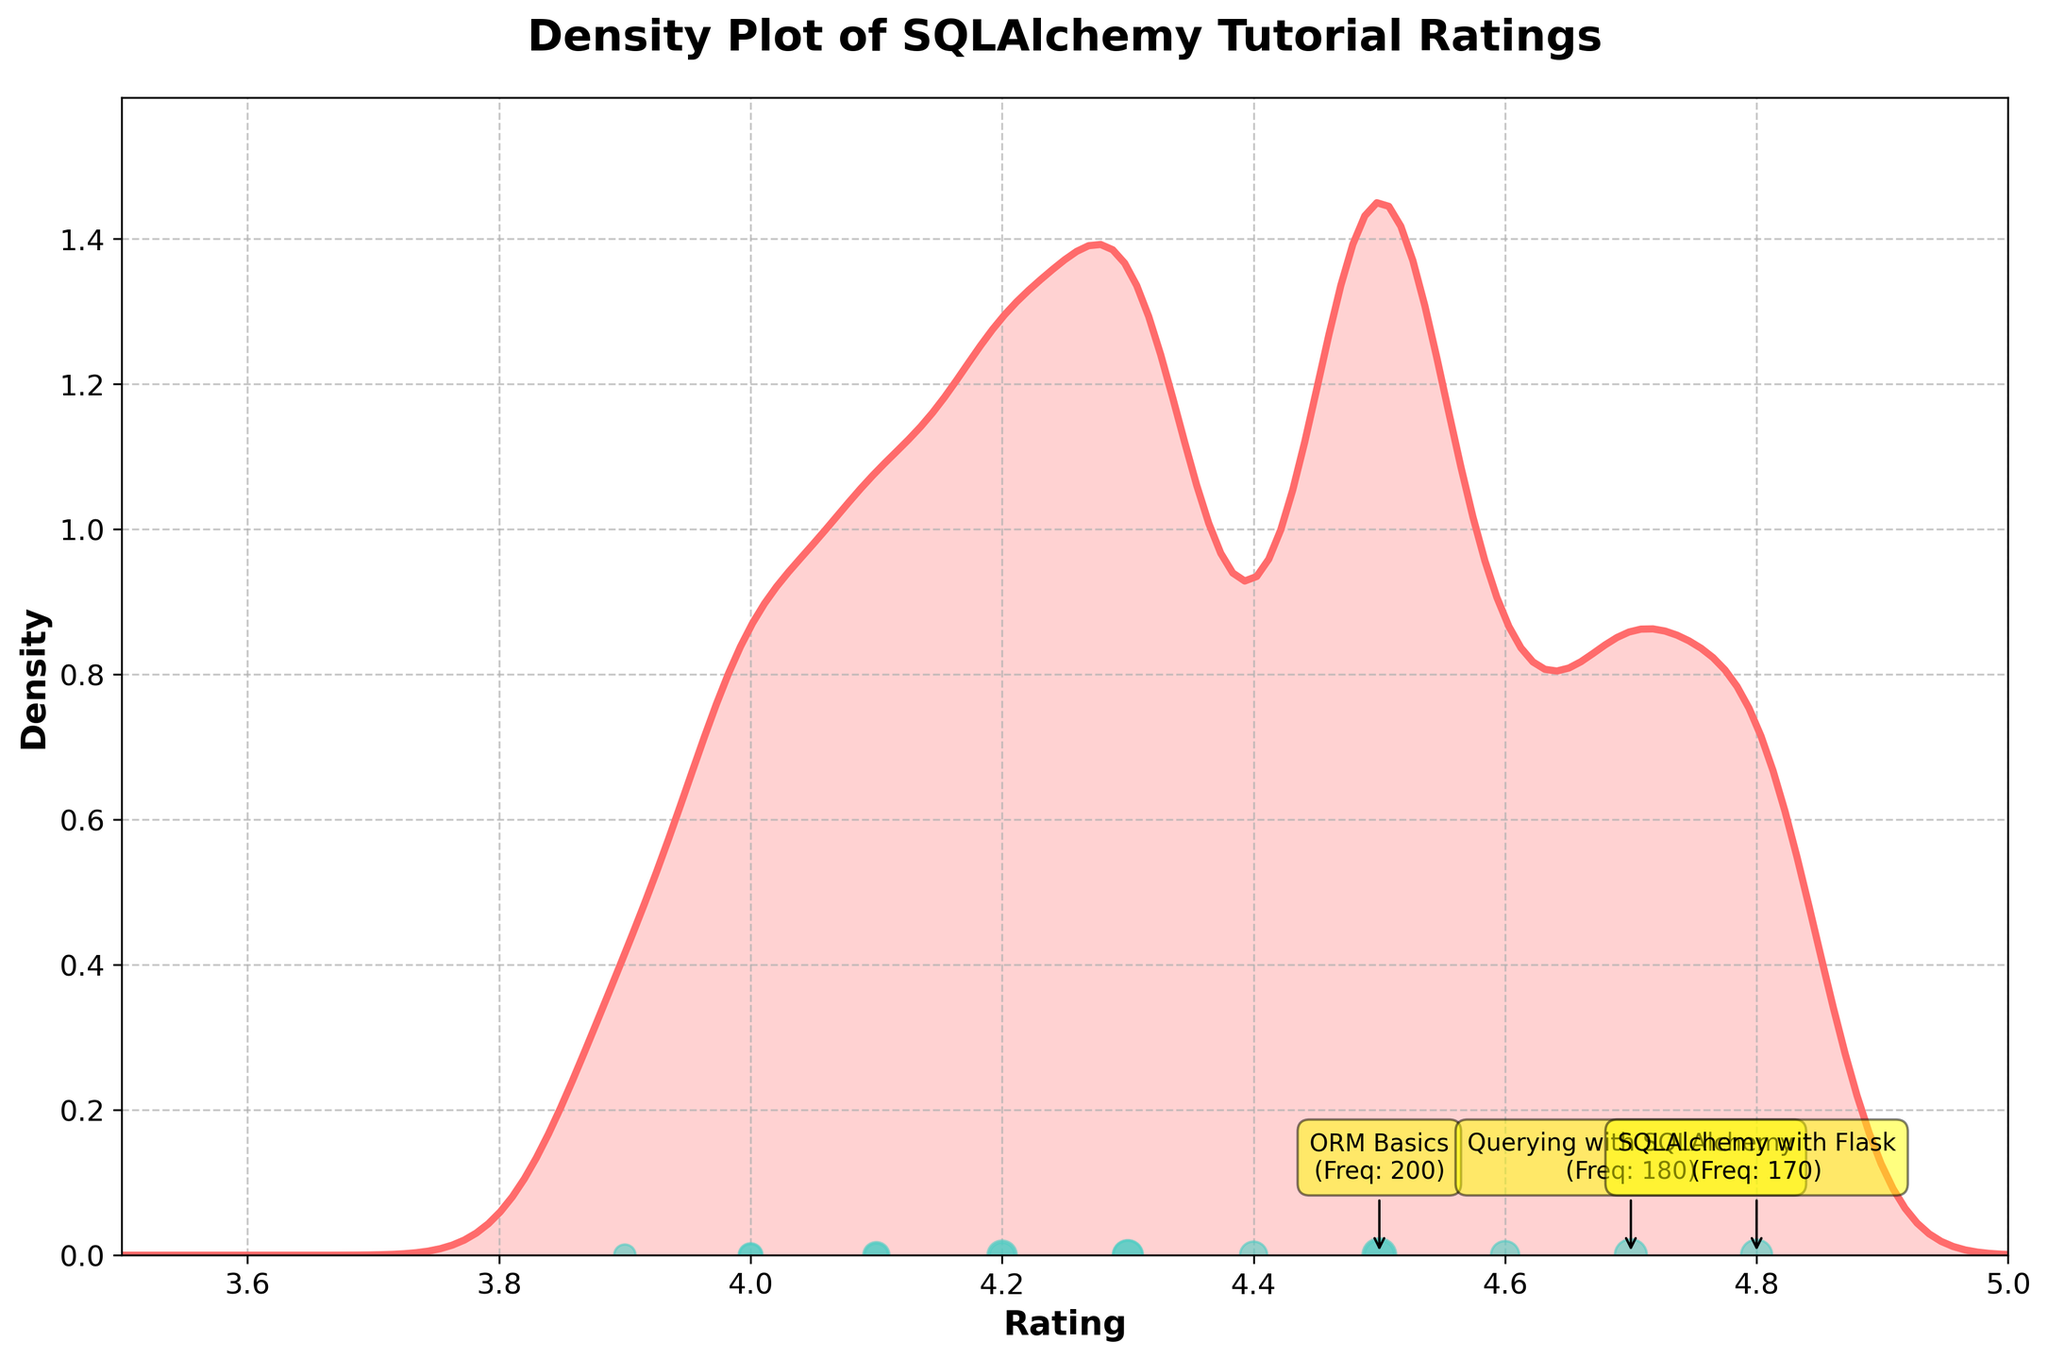What is the title of the figure? The title is prominently displayed at the top of the figure. The title typically summarizes the focus of the plot.
Answer: Density Plot of SQLAlchemy Tutorial Ratings What are the minimum and maximum ratings shown on the x-axis? The x-axis ranges from 3.5 to 5.0, which is evident from the x-axis ticks.
Answer: 3.5, 5.0 Which tutorial topic has the highest frequency, and what is that frequency? The top 3 topics are annotated in the plot. "ORM Basics" has the highest frequency of 200.
Answer: ORM Basics, 200 Which color represents the density plot, and which color represents the data points? The density plot is shown in a red hue (#FF6B6B), while the data points (scatter plot) are in a teal color (#4ECDC4).
Answer: Red for density, teal for data points What is the approximate density value at a rating of 4.5? The density value at each rating is indicated by the height of the curve. At a rating of 4.5, the density is approximately 0.25.
Answer: ~0.25 How many tutorial topics have a rating of 4.0? Observing the scatter points on the x-axis, the points at rating 4.0 correspond to "Migrations with Alembic" and "Hybrid Properties".
Answer: 2 What is the range of ratings covered by the most popular tutorials? The annotated top 3 tutorials ("ORM Basics", "Querying with SQLAlchemy", and "SQLAlchemy with Flask") have ratings between 4.5 and 4.8.
Answer: 4.5 to 4.8 Which tutorial topic has the lowest rating, and what is that rating? The scatter points reveal "SQLAlchemy Core" has the lowest rating of 3.9.
Answer: SQLAlchemy Core, 3.9 Which has a higher frequency: "Performance Optimization" or "Data Modeling Best Practices"? By examining both annotated frequencies, "Data Modeling Best Practices" has 145, while "Performance Optimization" has 130.
Answer: Data Modeling Best Practices What is the spread of ratings where the density is highest? The density peak appears to be around ratings 4.3 to 4.7 where the density values are higher, indicating more concentrated values in this spread.
Answer: 4.3 to 4.7 